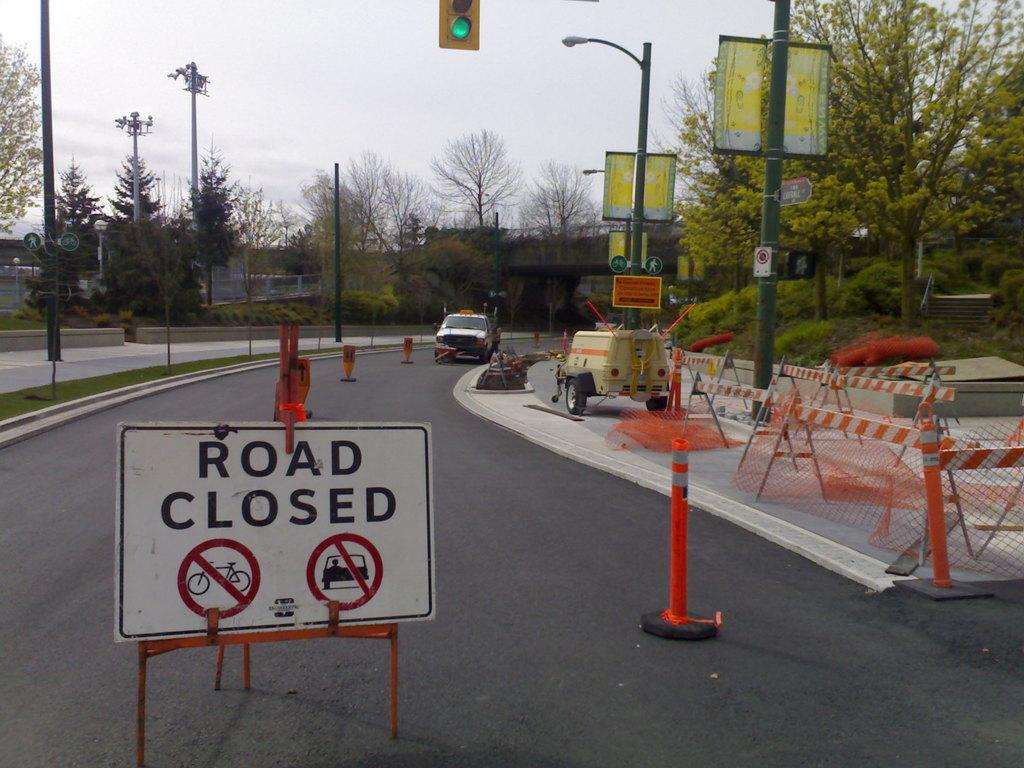<image>
Provide a brief description of the given image. Cones sitting in a road that is marked road closed 